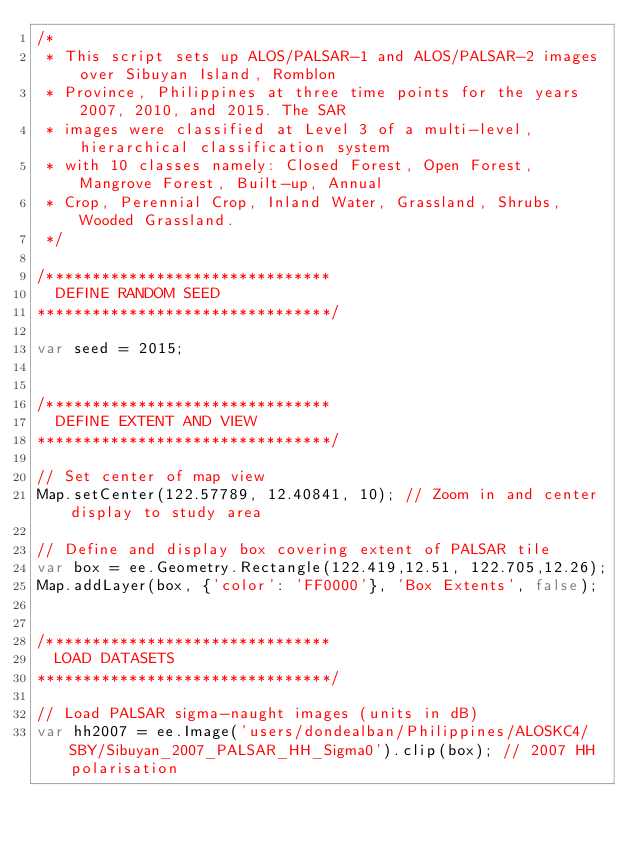<code> <loc_0><loc_0><loc_500><loc_500><_JavaScript_>/* 
 * This script sets up ALOS/PALSAR-1 and ALOS/PALSAR-2 images over Sibuyan Island, Romblon 
 * Province, Philippines at three time points for the years 2007, 2010, and 2015. The SAR 
 * images were classified at Level 3 of a multi-level, hierarchical classification system
 * with 10 classes namely: Closed Forest, Open Forest, Mangrove Forest, Built-up, Annual
 * Crop, Perennial Crop, Inland Water, Grassland, Shrubs, Wooded Grassland.
 */

/*******************************
  DEFINE RANDOM SEED
********************************/

var seed = 2015;


/*******************************
  DEFINE EXTENT AND VIEW
********************************/

// Set center of map view
Map.setCenter(122.57789, 12.40841, 10); // Zoom in and center display to study area

// Define and display box covering extent of PALSAR tile
var box = ee.Geometry.Rectangle(122.419,12.51, 122.705,12.26);
Map.addLayer(box, {'color': 'FF0000'}, 'Box Extents', false);


/*******************************
  LOAD DATASETS
********************************/

// Load PALSAR sigma-naught images (units in dB)
var hh2007 = ee.Image('users/dondealban/Philippines/ALOSKC4/SBY/Sibuyan_2007_PALSAR_HH_Sigma0').clip(box); // 2007 HH polarisation</code> 